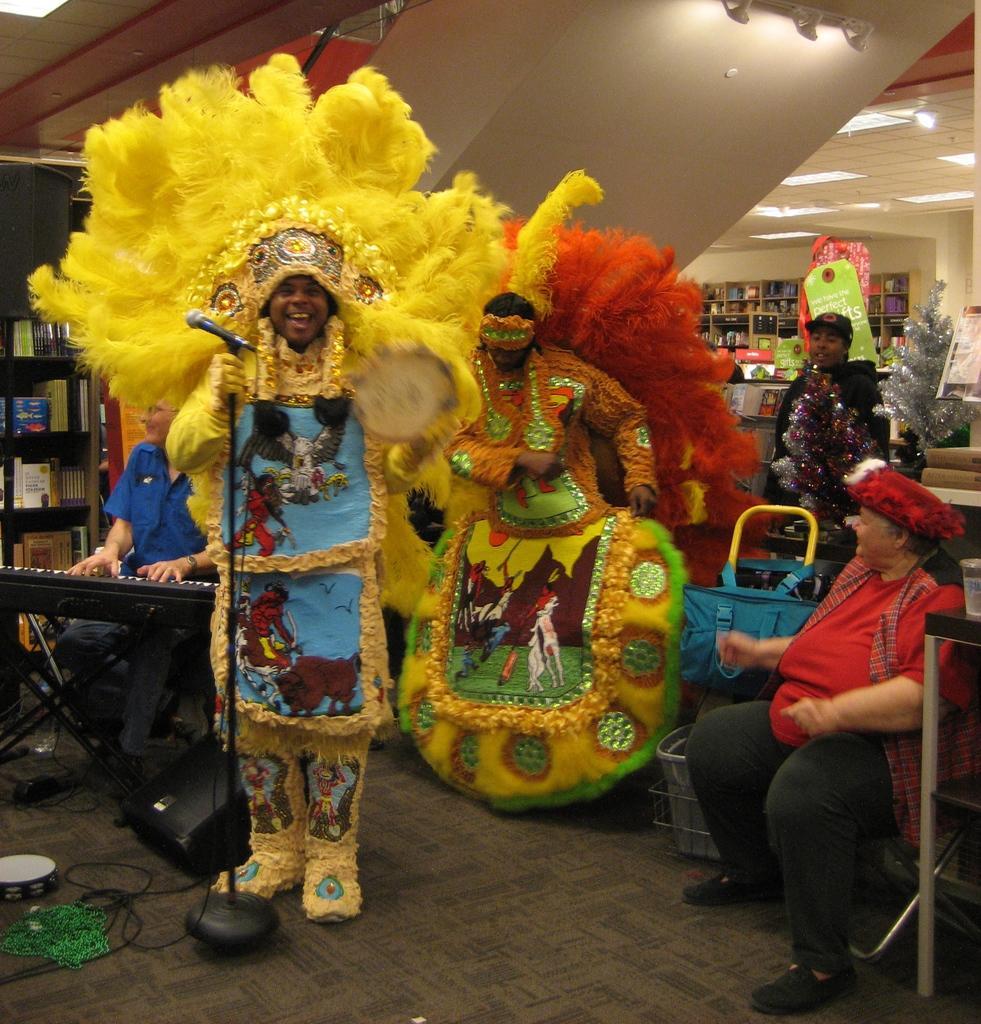In one or two sentences, can you explain what this image depicts? In this picture we can see a mic, bag, basket, wire, chairs, lights, books and some objects and a group of people where a person playing a keyboard and two people wore costumes and standing on the floor. 